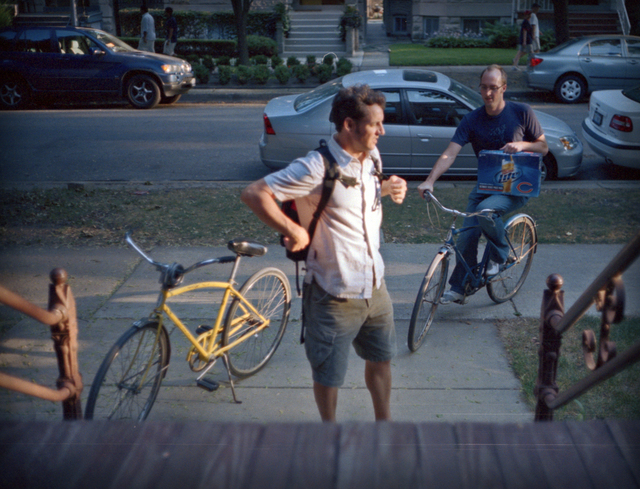What details in the image suggest personal or social aspects about the characters shown? The individuals in the image suggest a casual, possibly familiar interaction. One person is adjusting his backpack, possibly preparing to depart or just arriving, indicating a transitional moment. The other sitting passively on his bike, with a relaxed posture, suggests he is in no hurry, waiting or enjoying a casual conversation. Their attire is informal and practical, hinting that they value comfort and functionality, suitable for everyday tasks or leisurely activities. 